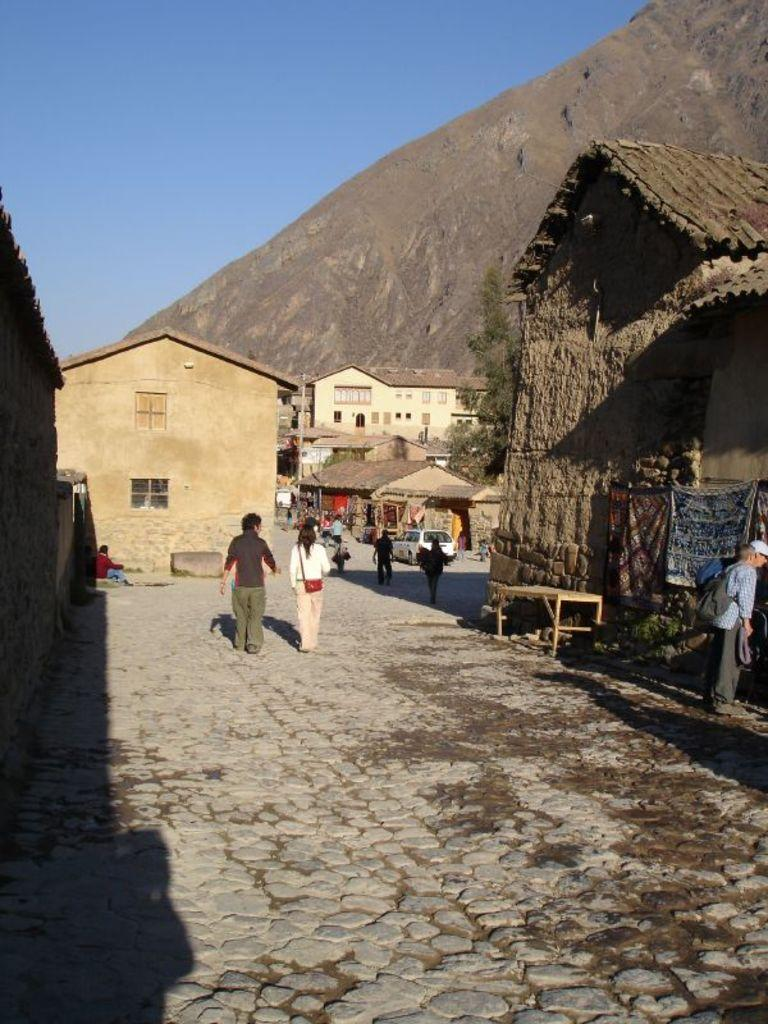What are the people in the image doing? The people in the image are walking. What type of structures can be seen in the image? There are houses in the image. Where is the bench located in the image? The bench is on the right side of the image. What can be seen in the background of the image? There is a hill and the sky visible in the background of the image. Where is the pump located in the image? There is no pump present in the image. What type of shelf can be seen on the hill in the background? There is no shelf visible in the image, as it only shows a hill in the background. 